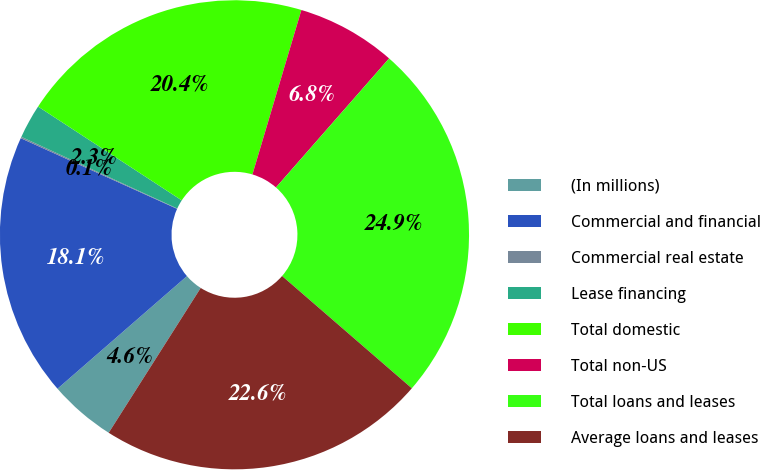<chart> <loc_0><loc_0><loc_500><loc_500><pie_chart><fcel>(In millions)<fcel>Commercial and financial<fcel>Commercial real estate<fcel>Lease financing<fcel>Total domestic<fcel>Total non-US<fcel>Total loans and leases<fcel>Average loans and leases<nl><fcel>4.6%<fcel>18.15%<fcel>0.1%<fcel>2.35%<fcel>20.4%<fcel>6.85%<fcel>24.9%<fcel>22.65%<nl></chart> 